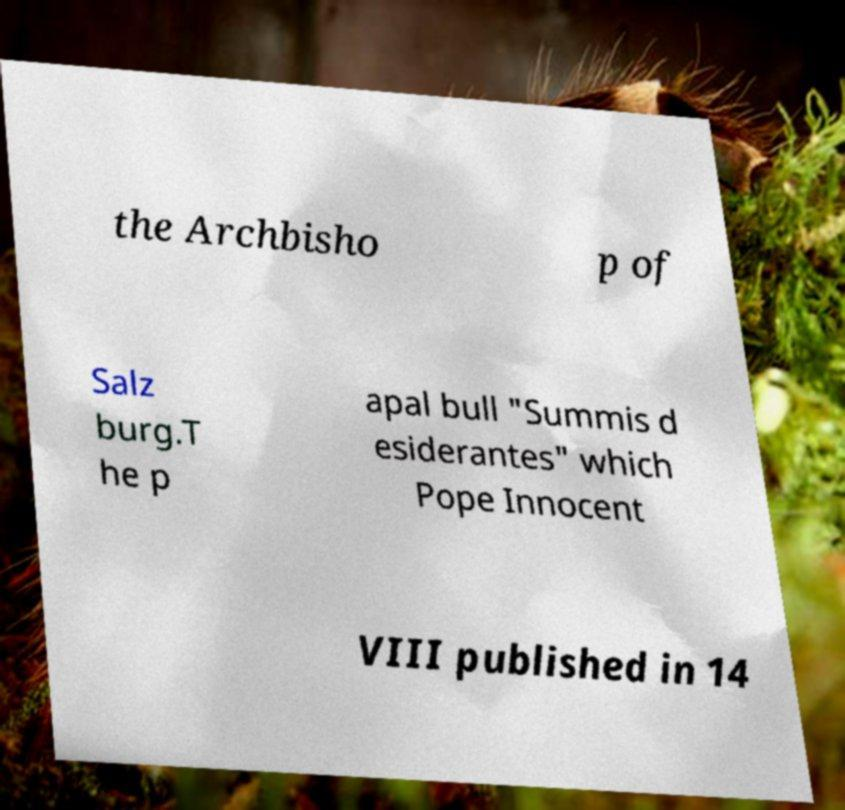Could you extract and type out the text from this image? the Archbisho p of Salz burg.T he p apal bull "Summis d esiderantes" which Pope Innocent VIII published in 14 